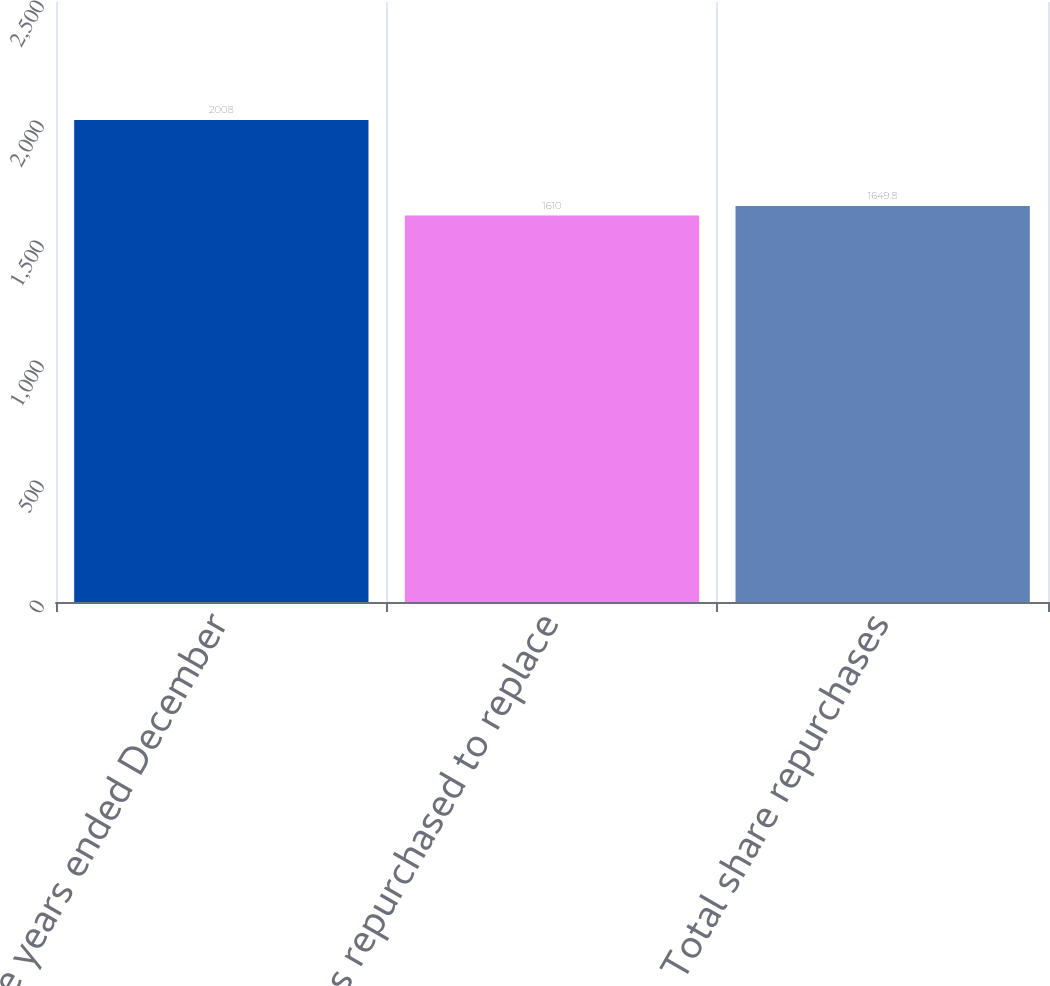<chart> <loc_0><loc_0><loc_500><loc_500><bar_chart><fcel>For the years ended December<fcel>Shares repurchased to replace<fcel>Total share repurchases<nl><fcel>2008<fcel>1610<fcel>1649.8<nl></chart> 